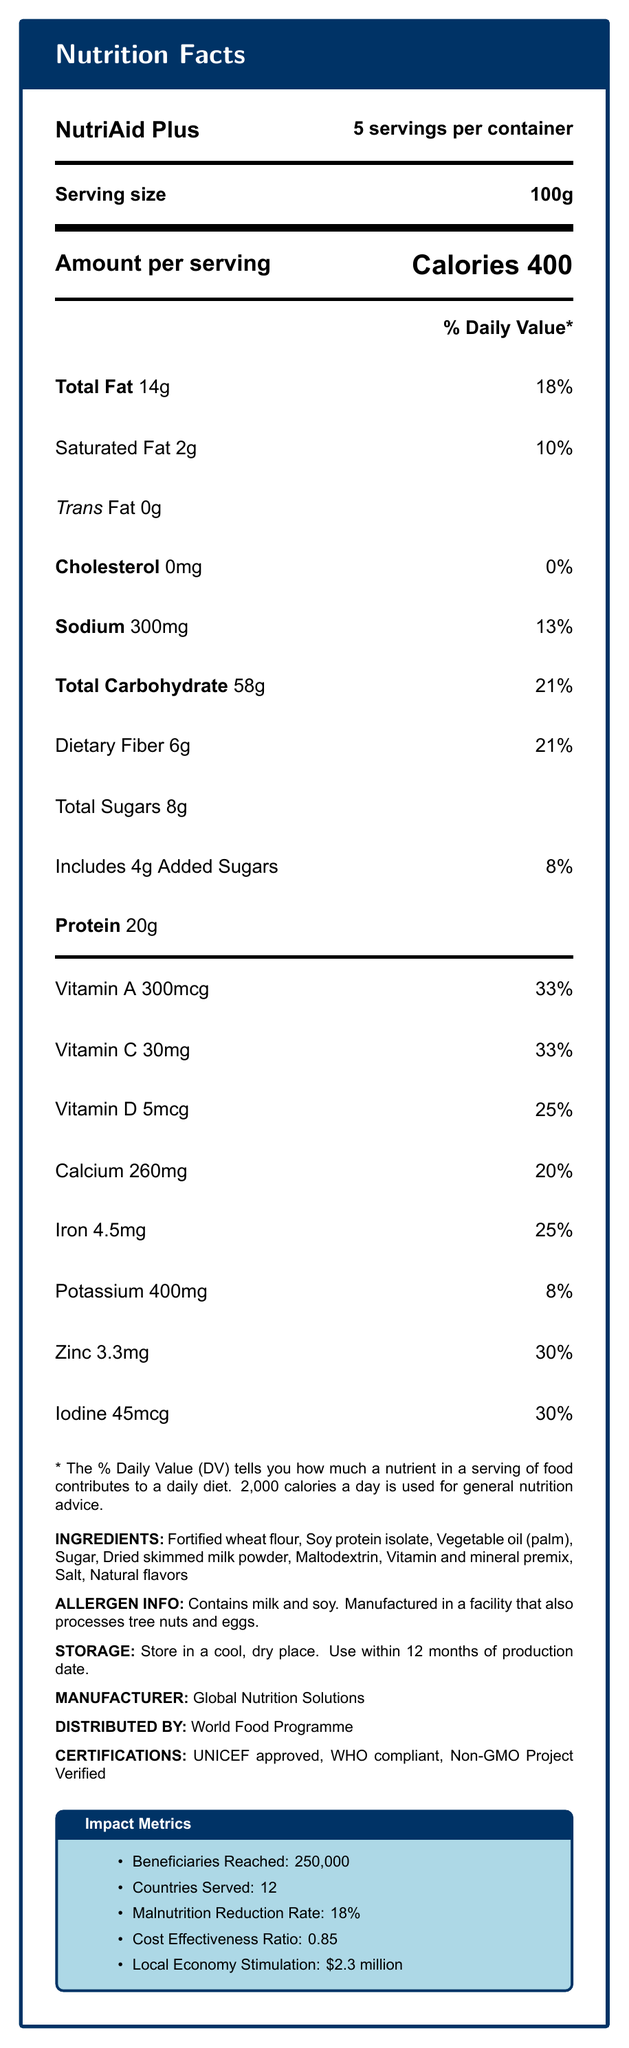what is the serving size? The serving size is explicitly noted as "100g" in the document.
Answer: 100g how many servings are there per container? The number of servings per container is stated as "5 servings per container."
Answer: 5 how many calories are there per serving? The document lists "Calories 400" under the "Amount per serving" section.
Answer: 400 what is the amount of total fat per serving? "Total Fat" is listed at 14g in the amount per serving section.
Answer: 14g what is the daily value percentage of vitamin C? The document mentions that Vitamin C has a daily value percentage of 33%.
Answer: 33% what is the sodium content per serving? The sodium content per serving is 300mg, as indicated in the document.
Answer: 300mg List two major organizations that endorsed NutriAid Plus. A. FDA, WHO B. UNICEF, WHO C. FDA, UNICEF The document states "UNICEF approved" and "WHO compliant" under certifications.
Answer: B. UNICEF, WHO Which of the following nutrients has the lowest daily value percentage? A. Vitamin D B. Iron C. Potassium D. Iodine Potassium has the lowest daily value percentage at 8%.
Answer: C. Potassium is NutriAid Plus non-GMO? The document mentions that NutriAid Plus is "Non-GMO Project Verified" under certifications.
Answer: Yes Describe the main idea of this document. The document provides a comprehensive overview of NutriAid Plus, including its nutritional profile, the organizations that endorsed it, and key impact metrics for humanitarian aid.
Answer: NutriAid Plus is a fortified food product designed for humanitarian aid programs. The document details its nutritional information, ingredients, allergen info, storage instructions, manufacturer and distributor, impact metrics, and certifications. What is the percentage of daily value for dietary fiber? The daily value for dietary fiber is noted as 21% in the document.
Answer: 21% How many countries has NutriAid Plus served? Under impact metrics, the document states that NutriAid Plus has served 12 countries.
Answer: 12 Identify the main allergens in NutriAid Plus. The allergen information section states, "Contains milk and soy."
Answer: Milk and soy Which nutrient's daily value is 25%? A. Vitamin A B. Vitamin C C. Vitamin D D. Iron Vitamin D is listed with a daily value percentage of 25%.
Answer: C. Vitamin D What is the primary source of protein in NutriAid Plus? The primary source of protein is indicated as "Soy protein isolate" under the ingredients.
Answer: Soy protein isolate Can the malnutrition reduction rate be deduced from the visual information on the document? The document explicitly lists the malnutrition reduction rate as 18%.
Answer: Yes What is the storage instruction for NutriAid Plus? The storage instructions are clearly mentioned within the document.
Answer: Store in a cool, dry place. Use within 12 months of production date. What is the cost effectiveness ratio of NutriAid Plus? The cost effectiveness ratio is provided under the impact metrics section.
Answer: 0.85 Where is NutriAid Plus manufactured? The manufacturer is listed as "Global Nutrition Solutions."
Answer: Global Nutrition Solutions What are the natural flavors in NutriAid Plus? The document does not specify what the natural flavors are.
Answer: Not enough information 